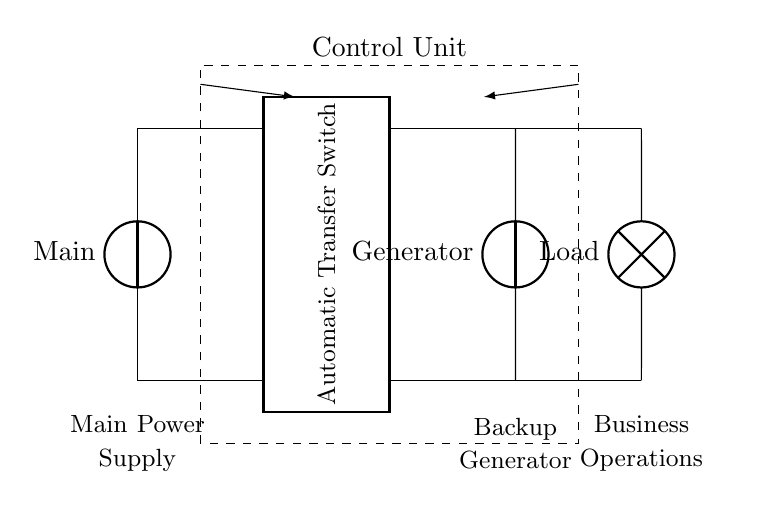What is the main power source in the circuit? The main power source is labeled as "Main" in the circuit diagram, connected to a vertical voltage source symbol representing the primary electricity supply.
Answer: Main What does the rectangular component represent? The rectangular component is labeled "Automatic Transfer Switch," indicating its role in switching between the main power supply and the backup generator during power outages.
Answer: Automatic Transfer Switch What is the role of the control unit? The control unit manages the operations of both the main power supply and the generator, which is indicated by the dashed rectangle that includes these elements, suggesting its controlling functionality.
Answer: Control Unit How many sources of power are present in the circuit? The circuit includes two sources of power: the main power supply and the backup generator, each represented by a voltage source symbol in the diagram.
Answer: Two What does the load symbolize in this circuit? The load is represented by a lamp symbol in the diagram, suggesting that it is the component that uses the electrical power supplied by either the main source or the generator for business operations.
Answer: Load What is the signal flow direction from the main power supply? The signal flows from the main power source towards the automatic transfer switch, as indicated by the arrow pointing from the main supply to the switch in the diagram.
Answer: Toward the switch When the main power fails, which component takes over? The backup generator takes over during a power failure as shown by its connection to the automatic transfer switch, which switches the load to the generator when there is no main power.
Answer: Backup Generator 